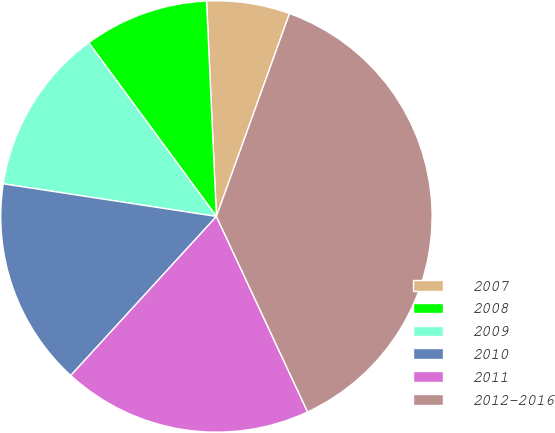Convert chart. <chart><loc_0><loc_0><loc_500><loc_500><pie_chart><fcel>2007<fcel>2008<fcel>2009<fcel>2010<fcel>2011<fcel>2012-2016<nl><fcel>6.23%<fcel>9.36%<fcel>12.49%<fcel>15.62%<fcel>18.75%<fcel>37.55%<nl></chart> 